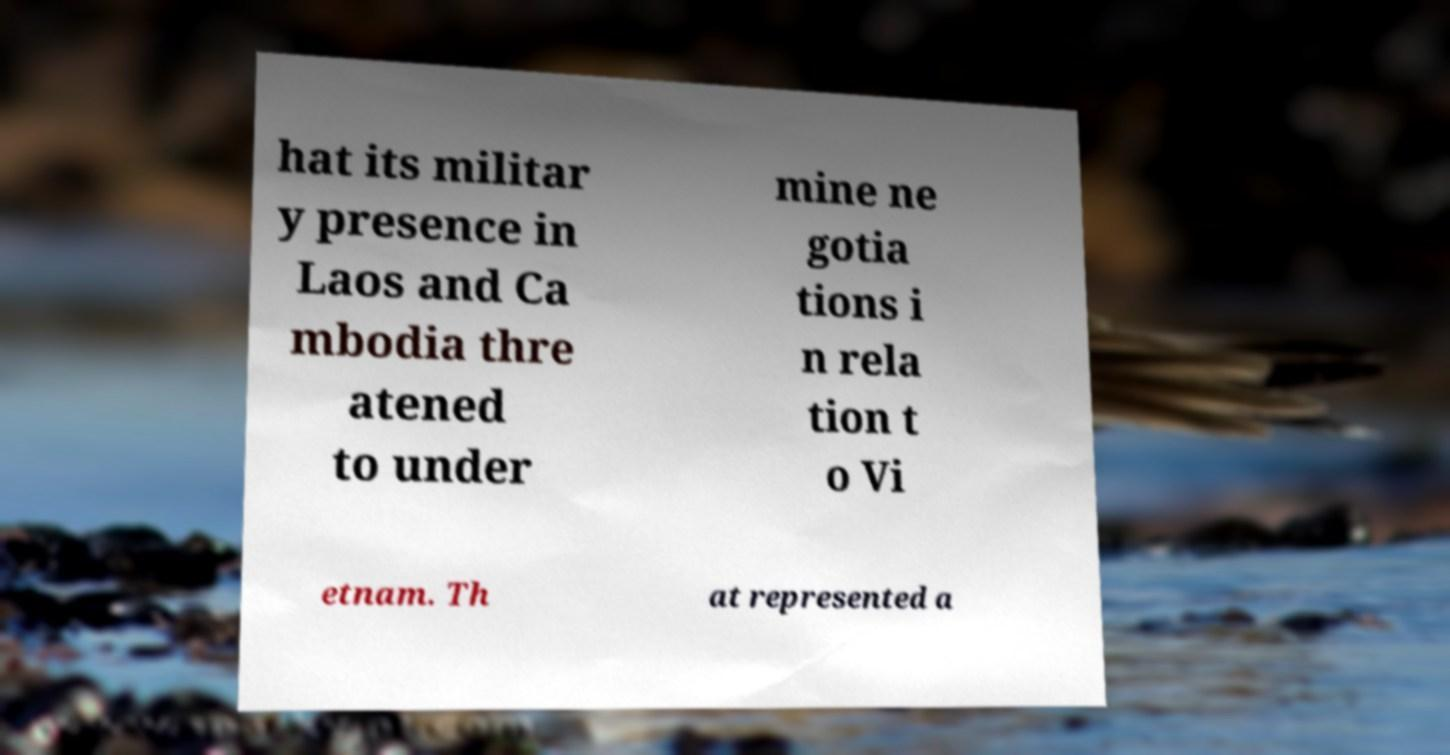Can you accurately transcribe the text from the provided image for me? hat its militar y presence in Laos and Ca mbodia thre atened to under mine ne gotia tions i n rela tion t o Vi etnam. Th at represented a 